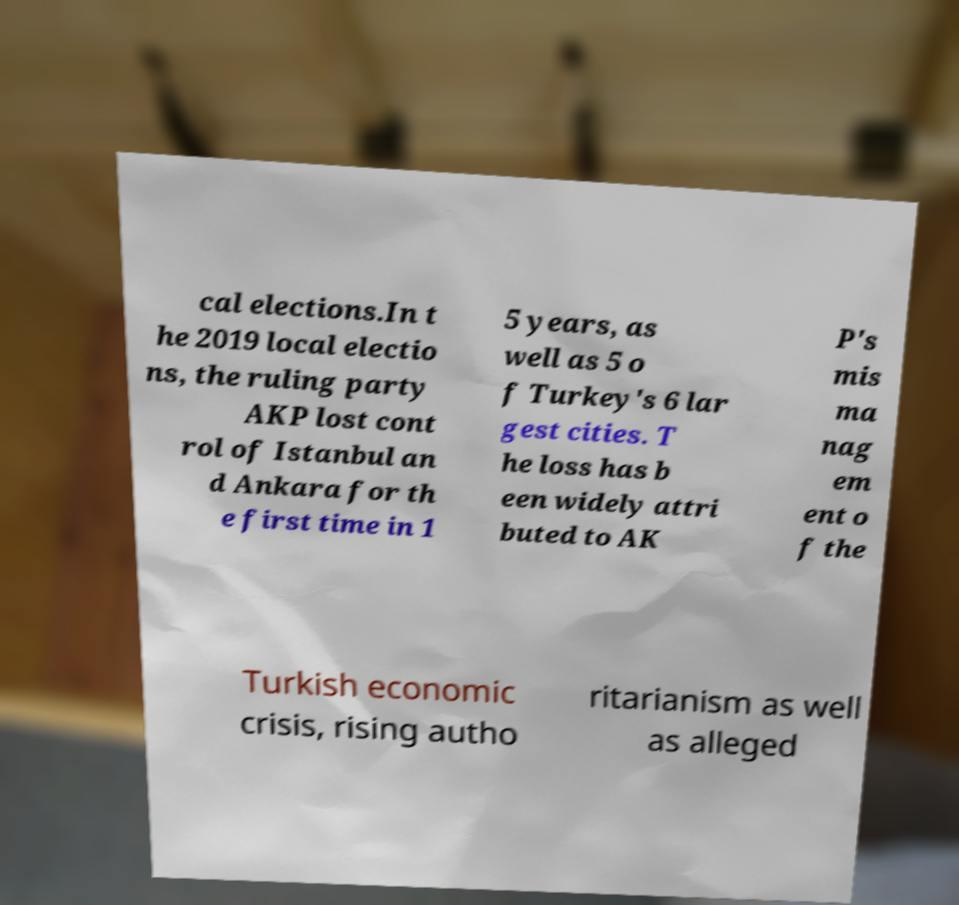Please read and relay the text visible in this image. What does it say? cal elections.In t he 2019 local electio ns, the ruling party AKP lost cont rol of Istanbul an d Ankara for th e first time in 1 5 years, as well as 5 o f Turkey's 6 lar gest cities. T he loss has b een widely attri buted to AK P's mis ma nag em ent o f the Turkish economic crisis, rising autho ritarianism as well as alleged 